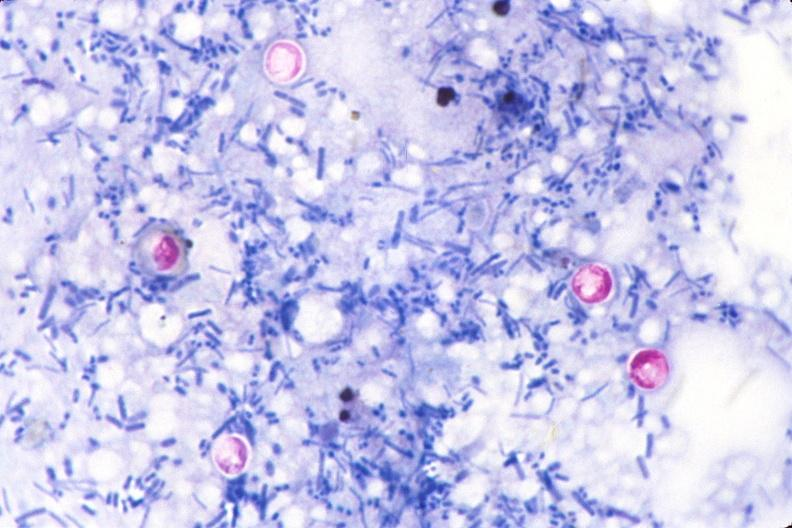what does this image show?
Answer the question using a single word or phrase. Cryptosporidia 